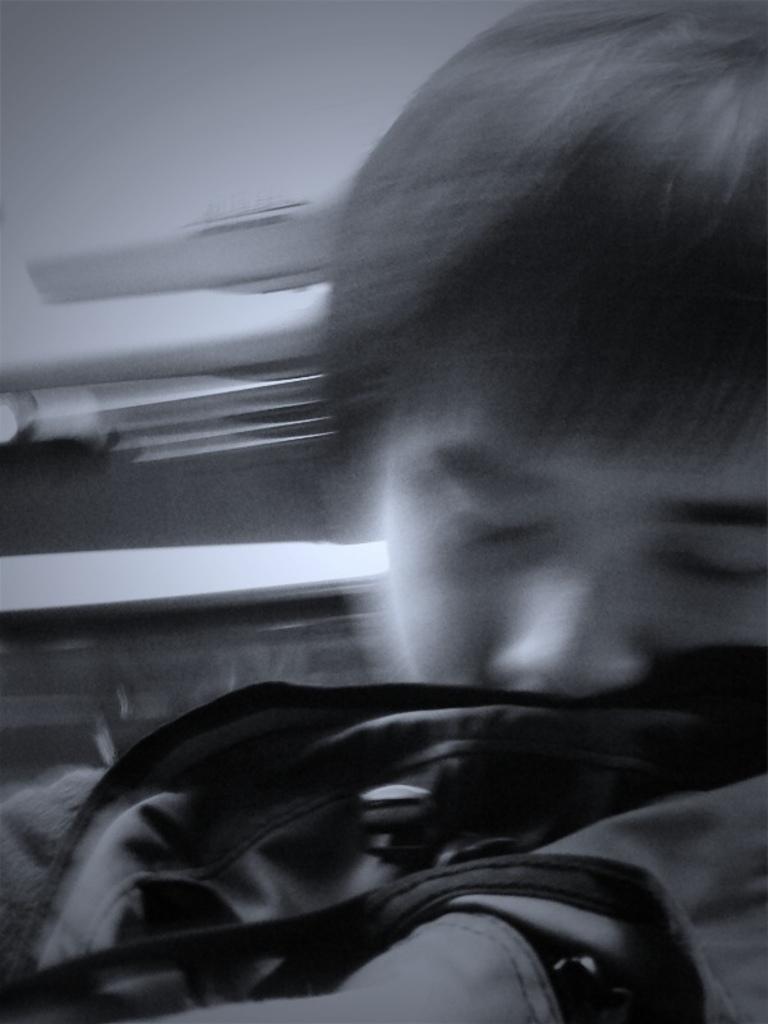Can you describe this image briefly? In this image we can see a man. In the background there is a wall. 